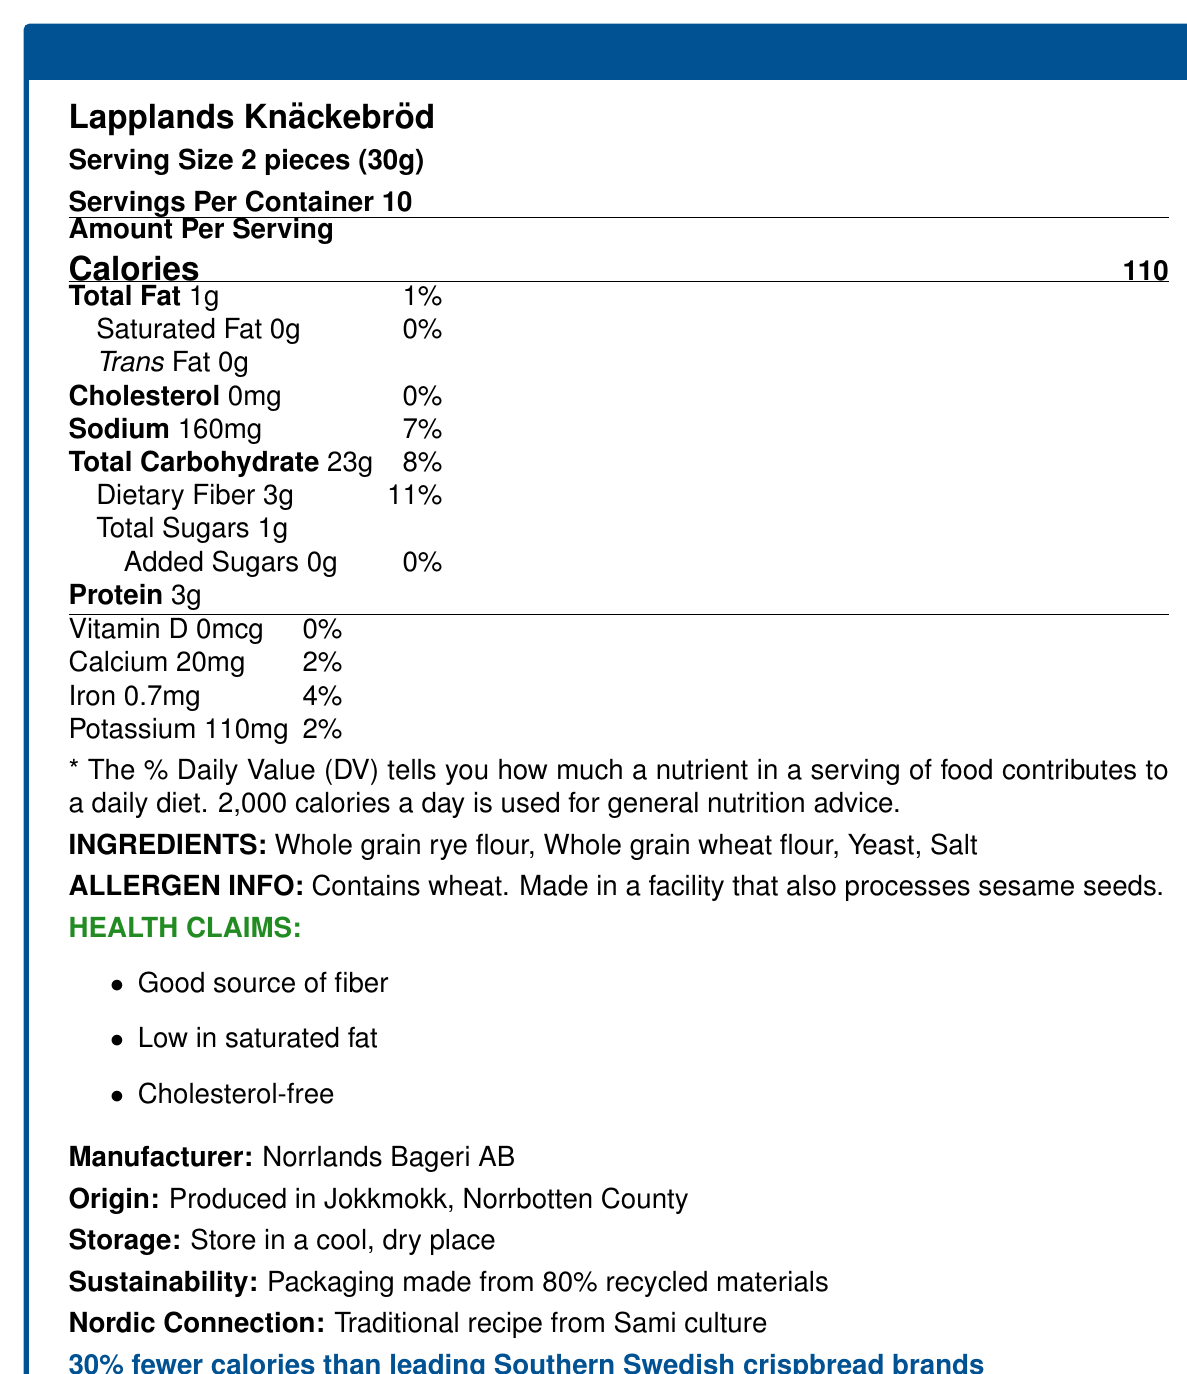What is the serving size for Lapplands Knäckebröd? The document states that the serving size for Lapplands Knäckebröd is 2 pieces, which equates to 30g.
Answer: 2 pieces (30g) How many servings are there per container? The nutrition facts label clearly indicates that there are 10 servings per container.
Answer: 10 How many calories are there per serving of Lapplands Knäckebröd? The document lists the amount of calories per serving as 110.
Answer: 110 What percentage of the Daily Value is the dietary fiber per serving? The dietary fiber per serving is 3g, and this represents 11% of the Daily Value.
Answer: 11% Does Lapplands Knäckebröd contain any trans fat? The label shows that the trans fat content per serving is 0g.
Answer: No How much iron does one serving of Lapplands Knäckebröd provide? According to the nutrition facts, there is 0.7mg of iron per serving.
Answer: 0.7mg Which of the following is NOT an ingredient in Lapplands Knäckebröd? A. Whole grain rye flour B. Whole grain wheat flour C. Yeast D. Sugar The ingredients listed are whole grain rye flour, whole grain wheat flour, yeast, and salt. Sugar is not included.
Answer: D. Sugar What is the sodium content per serving? A. 20mg B. 110mg C. 160mg D. 200mg The document shows that one serving contains 160mg of sodium.
Answer: C. 160mg Is this product made in Southern Sweden? Yes/No The product is produced in Jokkmokk, Norrbotten County, which is in Northern Sweden.
Answer: No Is Lapplands Knäckebröd a good source of fiber? The document includes in the health claims section that the product is a good source of fiber.
Answer: Yes What does "Norrlands Bageri AB" relate to in the document? The document lists Norrlands Bageri AB as the manufacturer of Lapplands Knäckebröd.
Answer: Manufacturer How much added sugars are in Lapplands Knäckebröd per serving? The nutrition facts specify that the product contains 0g of added sugars per serving.
Answer: 0g Summarize the main nutritional aspects and additional features of Lapplands Knäckebröd. The document provides detailed nutritional information, ingredient list, health claims, and additional features like packaging sustainability and calorie comparison with Southern Swedish brands.
Answer: Lapplands Knäckebröd is a low-calorie, high-fiber crispbread made from whole grain rye and wheat flour. It contains 110 calories per serving, is low in total and saturated fat, and has no cholesterol. The product is manufactured by Norrlands Bageri AB in Jokkmokk, Norrbotten County, and features health claims such as being a good source of fiber, low in saturated fat, and cholesterol-free. It is packaged in sustainable materials and has fewer calories compared to leading Southern Swedish brands. How much daily value does potassium contribute per serving? The document indicates that each serving of Lapplands Knäckebröd provides 110mg of potassium, which is 2% of the daily value.
Answer: 2% What is the origin of Lapplands Knäckebröd? The document states that the product is produced in Jokkmokk, Norrbotten County.
Answer: Jokkmokk, Norrbotten County Are sesame seeds processed in the same facility where Lapplands Knäckebröd is made? The allergen info indicates that the facility also processes sesame seeds.
Answer: Yes How many grams of protein are in two servings? Each serving contains 3g of protein. Therefore, two servings would have 6g of protein.
Answer: 6g What traditional culture is connected to the recipe of Lapplands Knäckebröd? The document notes that the recipe is traditional to Sami culture.
Answer: Sami culture What is the daily value percentage for calcium per serving? The document states that the calcium content per serving is 20mg, which is 2% of the daily value.
Answer: 2% What type of flour is used in Lapplands Knäckebröd? The ingredient list specifies both whole grain rye flour and whole grain wheat flour are used.
Answer: Whole grain rye flour and whole grain wheat flour Can the exact manufacturing date of Lapplands Knäckebröd be determined from the document? The document does not provide any information regarding the exact manufacturing date.
Answer: Not enough information 